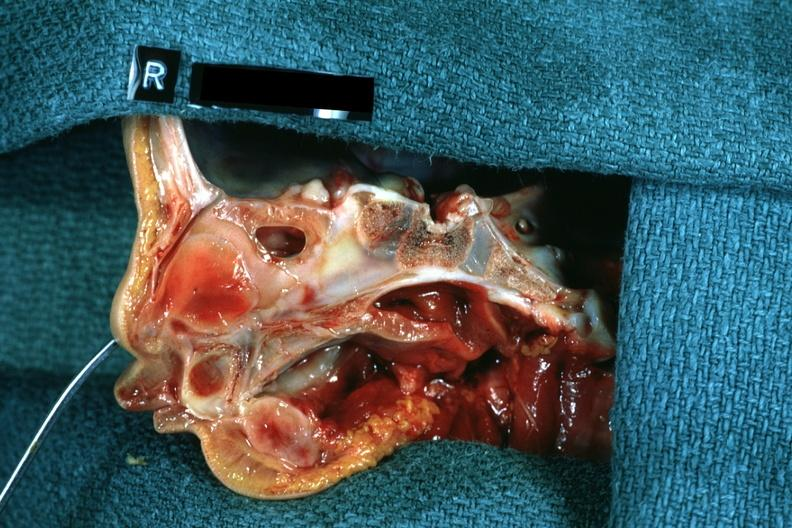what does this image show?
Answer the question using a single word or phrase. Right side atresia left was patent hemisection of nose 